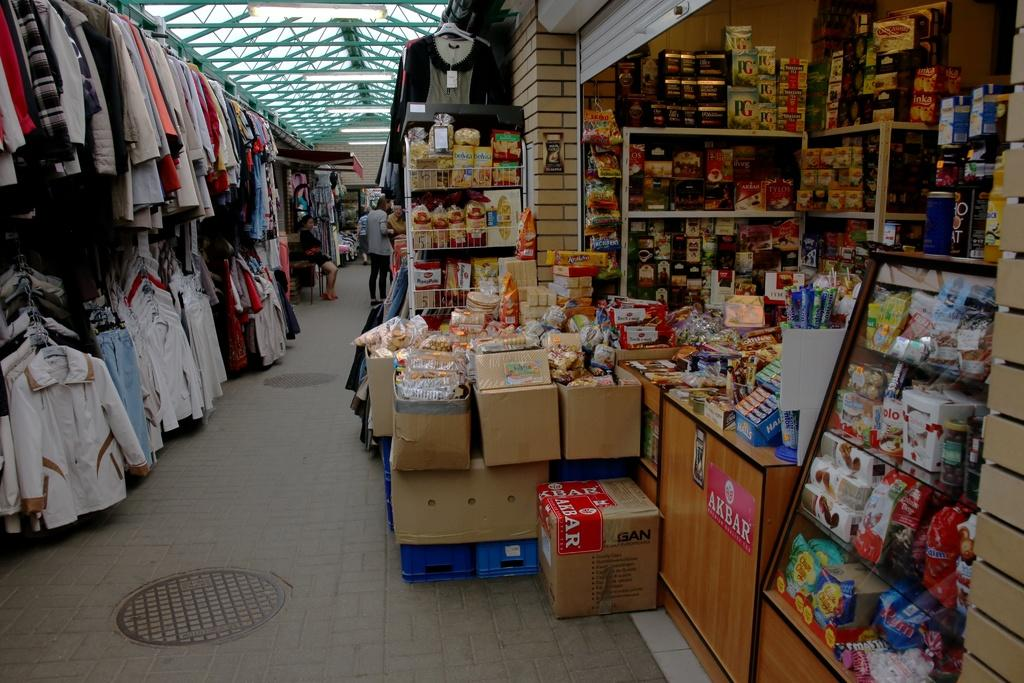<image>
Present a compact description of the photo's key features. A cluttered store has boxes on the floor with the word AKBAR on it. 